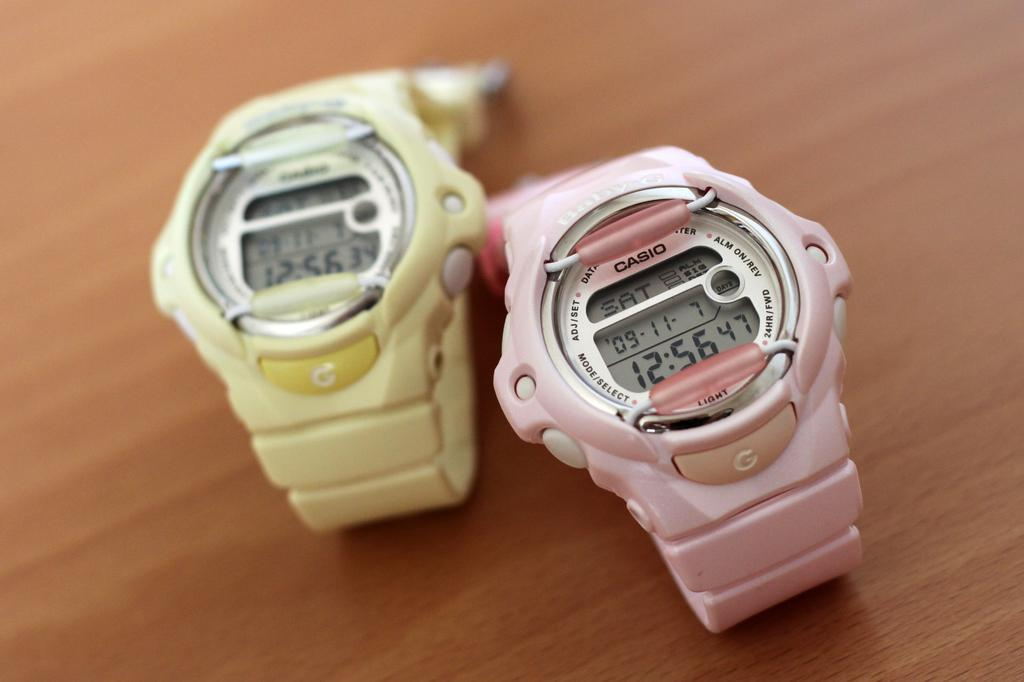<image>
Share a concise interpretation of the image provided. A pink and yellow Casio watch sitting next to each other on a table. 